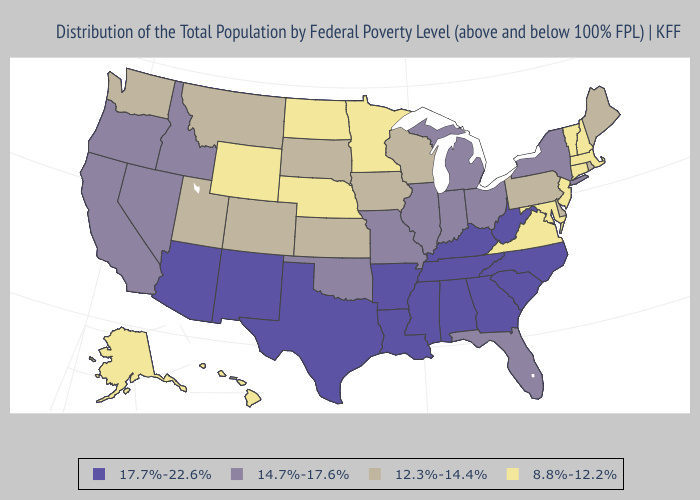Name the states that have a value in the range 8.8%-12.2%?
Answer briefly. Alaska, Connecticut, Hawaii, Maryland, Massachusetts, Minnesota, Nebraska, New Hampshire, New Jersey, North Dakota, Vermont, Virginia, Wyoming. Does Oklahoma have a higher value than Nevada?
Concise answer only. No. Which states have the lowest value in the USA?
Write a very short answer. Alaska, Connecticut, Hawaii, Maryland, Massachusetts, Minnesota, Nebraska, New Hampshire, New Jersey, North Dakota, Vermont, Virginia, Wyoming. What is the highest value in the South ?
Keep it brief. 17.7%-22.6%. Does Florida have the same value as Indiana?
Keep it brief. Yes. What is the lowest value in states that border Nevada?
Concise answer only. 12.3%-14.4%. What is the value of Oregon?
Concise answer only. 14.7%-17.6%. Name the states that have a value in the range 17.7%-22.6%?
Quick response, please. Alabama, Arizona, Arkansas, Georgia, Kentucky, Louisiana, Mississippi, New Mexico, North Carolina, South Carolina, Tennessee, Texas, West Virginia. What is the value of Rhode Island?
Be succinct. 12.3%-14.4%. What is the lowest value in the South?
Concise answer only. 8.8%-12.2%. What is the value of Maine?
Answer briefly. 12.3%-14.4%. What is the value of Florida?
Keep it brief. 14.7%-17.6%. What is the value of Wisconsin?
Give a very brief answer. 12.3%-14.4%. Does Missouri have the lowest value in the USA?
Concise answer only. No. Which states hav the highest value in the West?
Give a very brief answer. Arizona, New Mexico. 